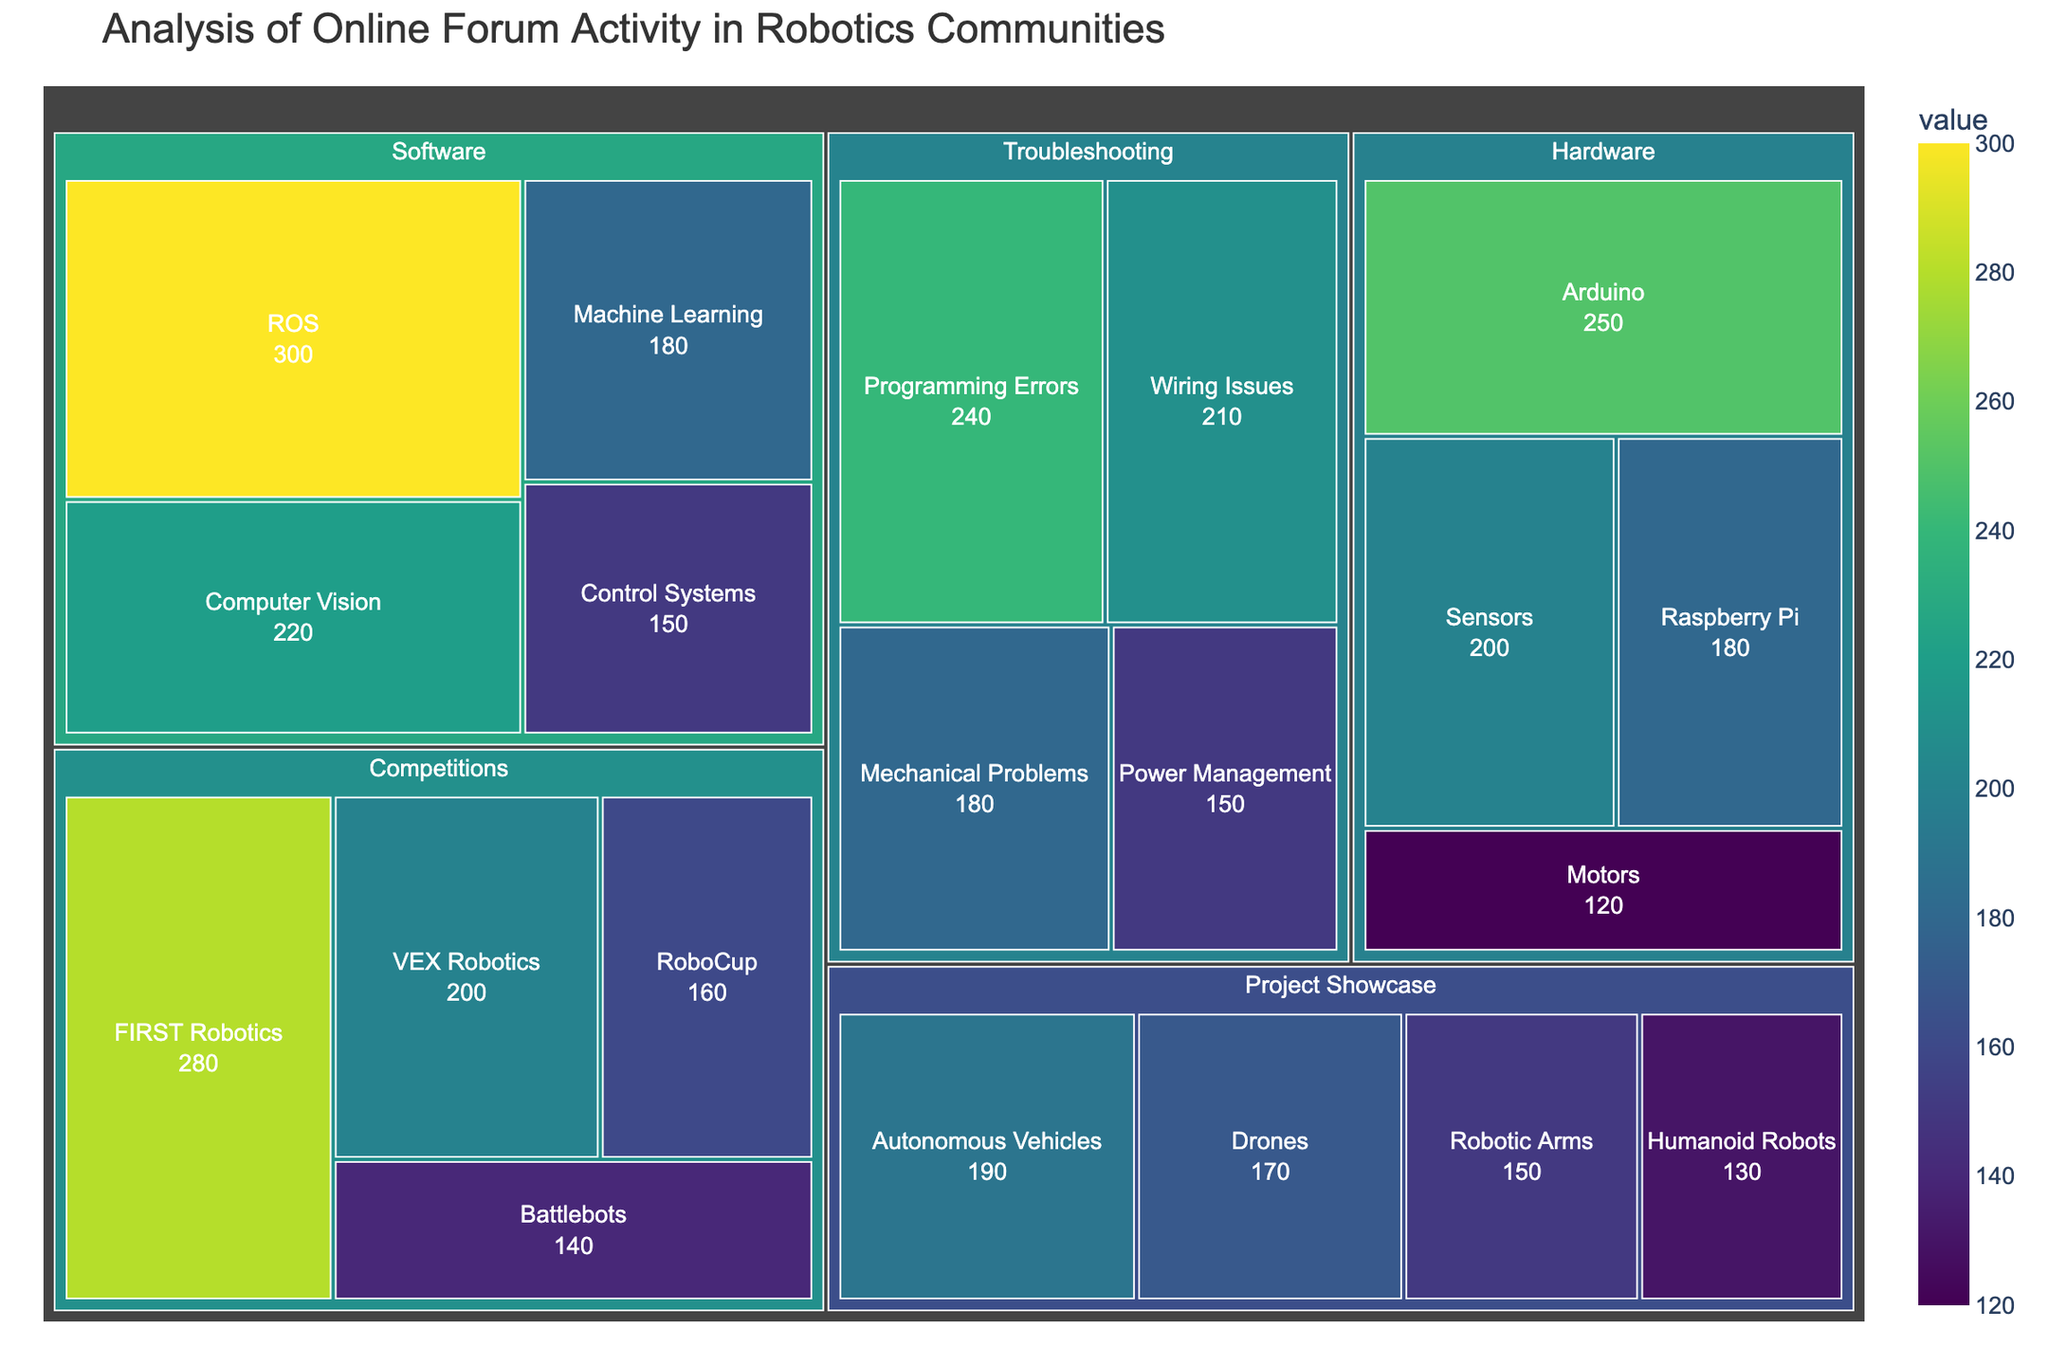What is the title of the treemap? The title of the treemap is displayed prominently at the top of the figure. It typically provides an overview of the data represented.
Answer: Analysis of Online Forum Activity in Robotics Communities Which subcategory has the highest number of posts? Identify the subcategories and their corresponding values from the treemap. The subcategory with the highest value has the most posts.
Answer: ROS How many posts are there in the 'Hardware' category in total? Sum up the values of all subcategories under the 'Hardware' category. 250 (Arduino) + 180 (Raspberry Pi) + 120 (Motors) + 200 (Sensors) = 750
Answer: 750 Which category has a higher number of posts: 'Competitions' or 'Project Showcase'? Compare the total number of posts in 'Competitions' and 'Project Showcase'. Sum the values of their subcategories: Competitions: 280 + 200 + 160 + 140 = 780, Project Showcase: 190 + 150 + 170 + 130 = 640
Answer: Competitions What is the second most active subcategory in 'Troubleshooting'? List the subcategories under 'Troubleshooting' and their corresponding values, then identify the second highest value. Subcategories: Wiring Issues (210), Programming Errors (240), Mechanical Problems (180), Power Management (150). The second highest value is 210 (Wiring Issues).
Answer: Wiring Issues How many more posts are there in 'FIRST Robotics' compared to 'VEX Robotics'? Subtract the value of the 'VEX Robotics' subcategory from the 'FIRST Robotics' subcategory. 280 (FIRST Robotics) - 200 (VEX Robotics) = 80
Answer: 80 Which 'Software' subcategory has the lowest number of posts? Identify all subcategories under 'Software' and compare their values. The one with the smallest value is the lowest. Subcategories: ROS (300), Computer Vision (220), Machine Learning (180), Control Systems (150).
Answer: Control Systems Rank the categories from highest to lowest based on the total number of posts. Calculate the total number of posts for each category and then rank them accordingly: 'Competitions' (780), 'Troubleshooting' (780), 'Software' (850), 'Hardware' (750), 'Project Showcase' (640).
Answer: Software > Competitions = Troubleshooting > Hardware > Project Showcase What are the color variations used in the treemap? Examine the treemap's color scheme. The color variations are used to differentiate values and categories. Most likely identified through color names or general hues.
Answer: Various shades of Viridis (green to yellow) 